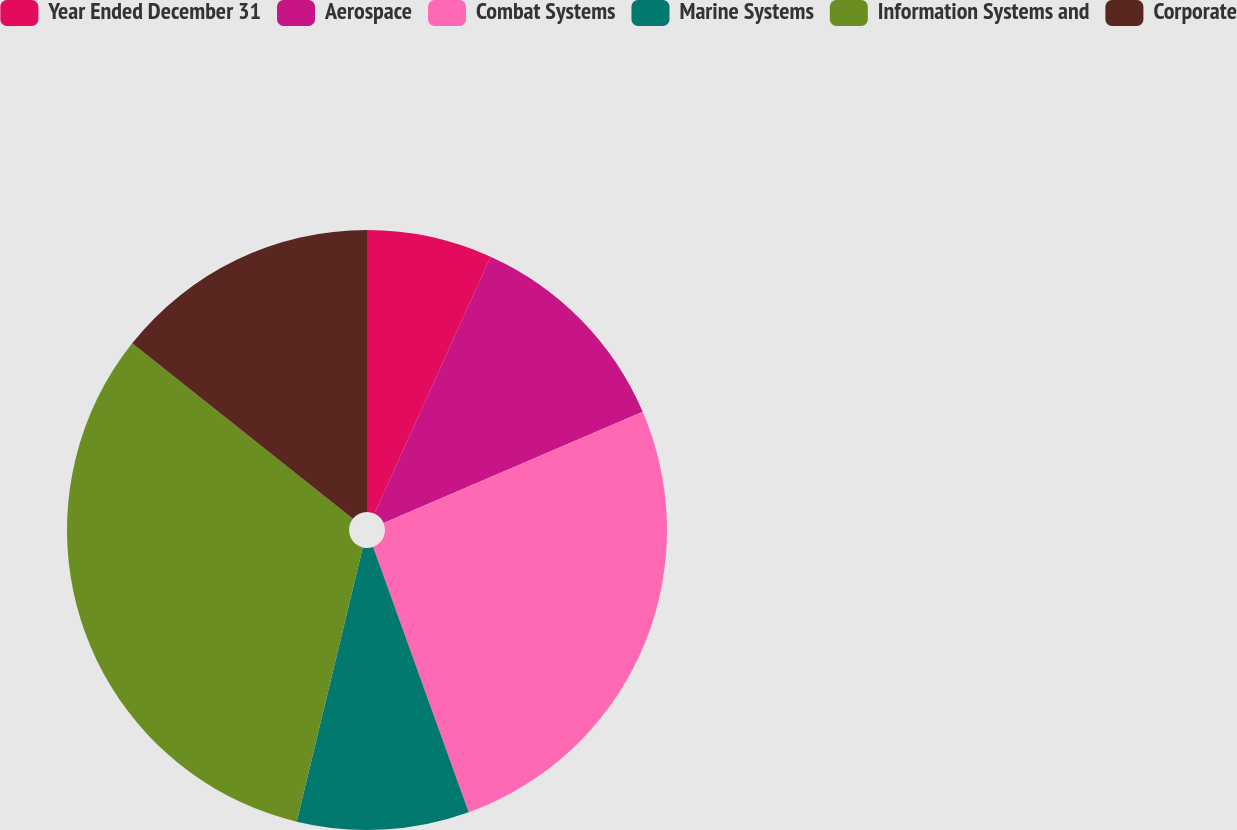Convert chart. <chart><loc_0><loc_0><loc_500><loc_500><pie_chart><fcel>Year Ended December 31<fcel>Aerospace<fcel>Combat Systems<fcel>Marine Systems<fcel>Information Systems and<fcel>Corporate<nl><fcel>6.76%<fcel>11.79%<fcel>25.95%<fcel>9.27%<fcel>31.93%<fcel>14.31%<nl></chart> 